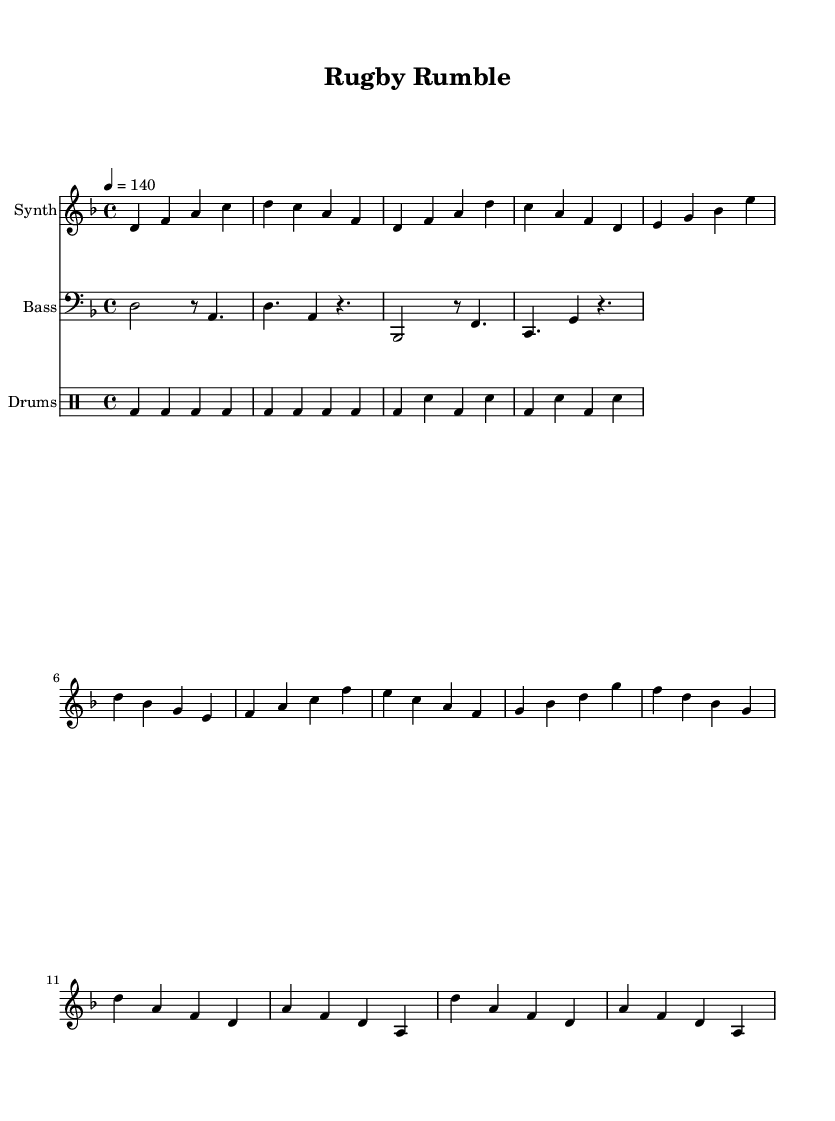What is the key signature of this music? The key signature is D minor, which has one flat (B flat). The sheet music indicates this by showing the flat sign next to the note B in the key signature at the beginning.
Answer: D minor What is the time signature of this piece? The time signature is 4/4, indicated at the beginning of the sheet music. This means there are four beats in each measure and the quarter note gets one beat.
Answer: 4/4 What is the tempo marking for this composition? The tempo marking is 140 beats per minute. It is indicated by the "4 = 140" in the tempo section, meaning each quarter note should be played at this speed.
Answer: 140 How many measures are in the verse section? The verse section consists of four measures, which can be counted by looking at the arrangement of notes in that section. Each measure is separated by a vertical bar.
Answer: 4 Identify the main instrument type featured in this piece. The main instrument type is "Synth", as indicated at the beginning of the staff where it states "instrumentName = 'Synth'." This tells us that the primary melody is played using synthesized sounds.
Answer: Synth Which rhythmic pattern is used for the drums? The rhythmic pattern for the drums includes the bass drum and snare hits organized in a steady rhythm, characterized by the "bd" and "sn" notation in the drum staff. This pattern repeats consistently throughout the piece, typical for electronic dance music.
Answer: Steady rhythm What is the maximum pitch note present in the synth section? The maximum pitch note in the synth section is C, which appears in the upper register noted in the measure where the fourth measure of the section contains it.
Answer: C 